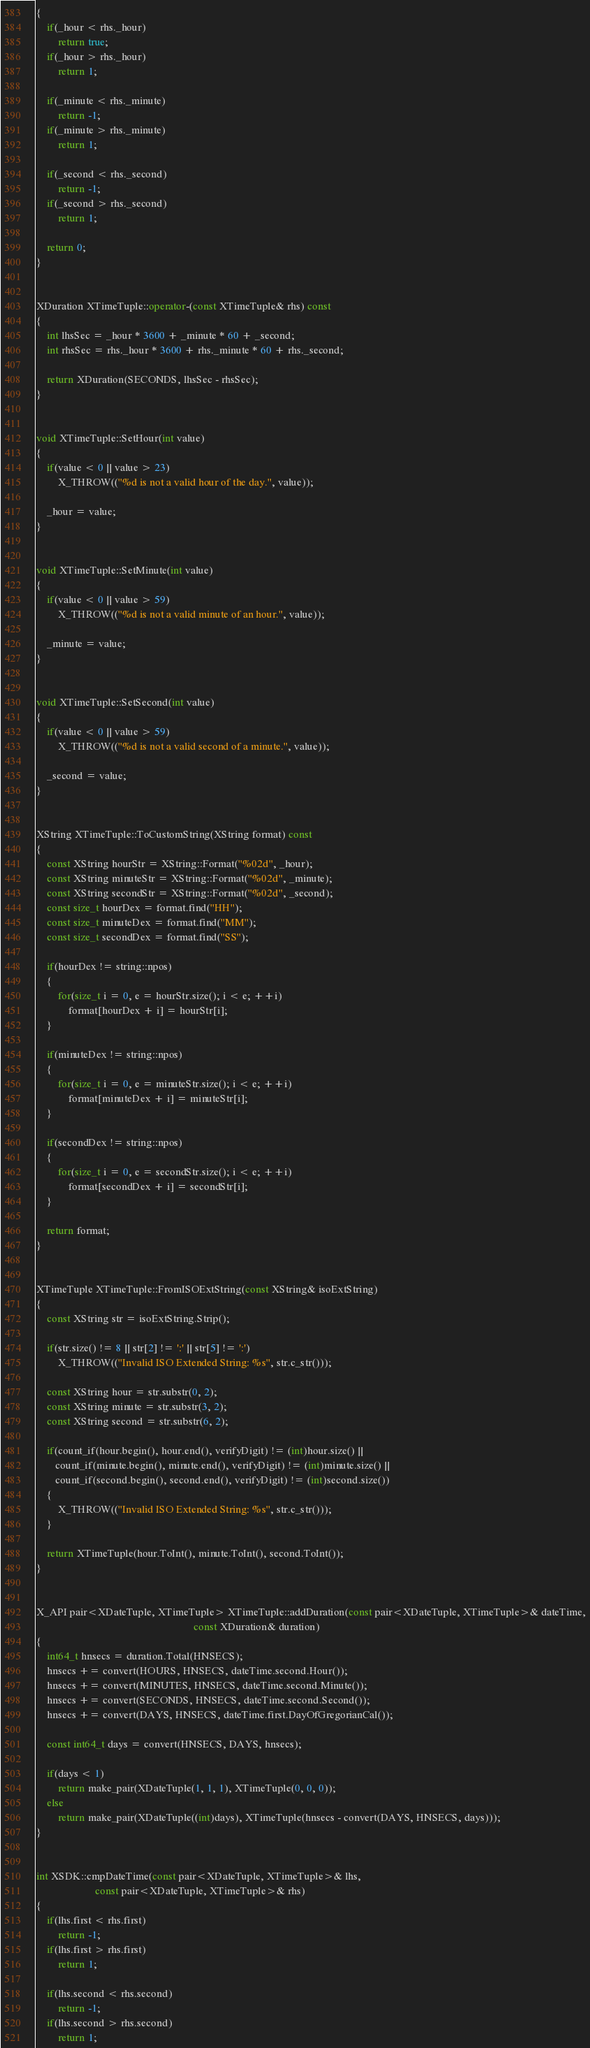<code> <loc_0><loc_0><loc_500><loc_500><_C++_>{
    if(_hour < rhs._hour)
        return true;
    if(_hour > rhs._hour)
        return 1;

    if(_minute < rhs._minute)
        return -1;
    if(_minute > rhs._minute)
        return 1;

    if(_second < rhs._second)
        return -1;
    if(_second > rhs._second)
        return 1;

    return 0;
}


XDuration XTimeTuple::operator-(const XTimeTuple& rhs) const
{
    int lhsSec = _hour * 3600 + _minute * 60 + _second;
    int rhsSec = rhs._hour * 3600 + rhs._minute * 60 + rhs._second;

    return XDuration(SECONDS, lhsSec - rhsSec);
}


void XTimeTuple::SetHour(int value)
{
    if(value < 0 || value > 23)
        X_THROW(("%d is not a valid hour of the day.", value));

    _hour = value;
}


void XTimeTuple::SetMinute(int value)
{
    if(value < 0 || value > 59)
        X_THROW(("%d is not a valid minute of an hour.", value));

    _minute = value;
}


void XTimeTuple::SetSecond(int value)
{
    if(value < 0 || value > 59)
        X_THROW(("%d is not a valid second of a minute.", value));

    _second = value;
}


XString XTimeTuple::ToCustomString(XString format) const
{
    const XString hourStr = XString::Format("%02d", _hour);
    const XString minuteStr = XString::Format("%02d", _minute);
    const XString secondStr = XString::Format("%02d", _second);
    const size_t hourDex = format.find("HH");
    const size_t minuteDex = format.find("MM");
    const size_t secondDex = format.find("SS");

    if(hourDex != string::npos)
    {
        for(size_t i = 0, e = hourStr.size(); i < e; ++i)
            format[hourDex + i] = hourStr[i];
    }

    if(minuteDex != string::npos)
    {
        for(size_t i = 0, e = minuteStr.size(); i < e; ++i)
            format[minuteDex + i] = minuteStr[i];
    }

    if(secondDex != string::npos)
    {
        for(size_t i = 0, e = secondStr.size(); i < e; ++i)
            format[secondDex + i] = secondStr[i];
    }

    return format;
}


XTimeTuple XTimeTuple::FromISOExtString(const XString& isoExtString)
{
    const XString str = isoExtString.Strip();

    if(str.size() != 8 || str[2] != ':' || str[5] != ':')
        X_THROW(("Invalid ISO Extended String: %s", str.c_str()));

    const XString hour = str.substr(0, 2);
    const XString minute = str.substr(3, 2);
    const XString second = str.substr(6, 2);

    if(count_if(hour.begin(), hour.end(), verifyDigit) != (int)hour.size() ||
       count_if(minute.begin(), minute.end(), verifyDigit) != (int)minute.size() ||
       count_if(second.begin(), second.end(), verifyDigit) != (int)second.size())
    {
        X_THROW(("Invalid ISO Extended String: %s", str.c_str()));
    }

    return XTimeTuple(hour.ToInt(), minute.ToInt(), second.ToInt());
}


X_API pair<XDateTuple, XTimeTuple> XTimeTuple::addDuration(const pair<XDateTuple, XTimeTuple>& dateTime,
                                                           const XDuration& duration)
{
    int64_t hnsecs = duration.Total(HNSECS);
    hnsecs += convert(HOURS, HNSECS, dateTime.second.Hour());
    hnsecs += convert(MINUTES, HNSECS, dateTime.second.Minute());
    hnsecs += convert(SECONDS, HNSECS, dateTime.second.Second());
    hnsecs += convert(DAYS, HNSECS, dateTime.first.DayOfGregorianCal());

    const int64_t days = convert(HNSECS, DAYS, hnsecs);

    if(days < 1)
        return make_pair(XDateTuple(1, 1, 1), XTimeTuple(0, 0, 0));
    else
        return make_pair(XDateTuple((int)days), XTimeTuple(hnsecs - convert(DAYS, HNSECS, days)));
}


int XSDK::cmpDateTime(const pair<XDateTuple, XTimeTuple>& lhs,
                      const pair<XDateTuple, XTimeTuple>& rhs)
{
    if(lhs.first < rhs.first)
        return -1;
    if(lhs.first > rhs.first)
        return 1;

    if(lhs.second < rhs.second)
        return -1;
    if(lhs.second > rhs.second)
        return 1;
</code> 